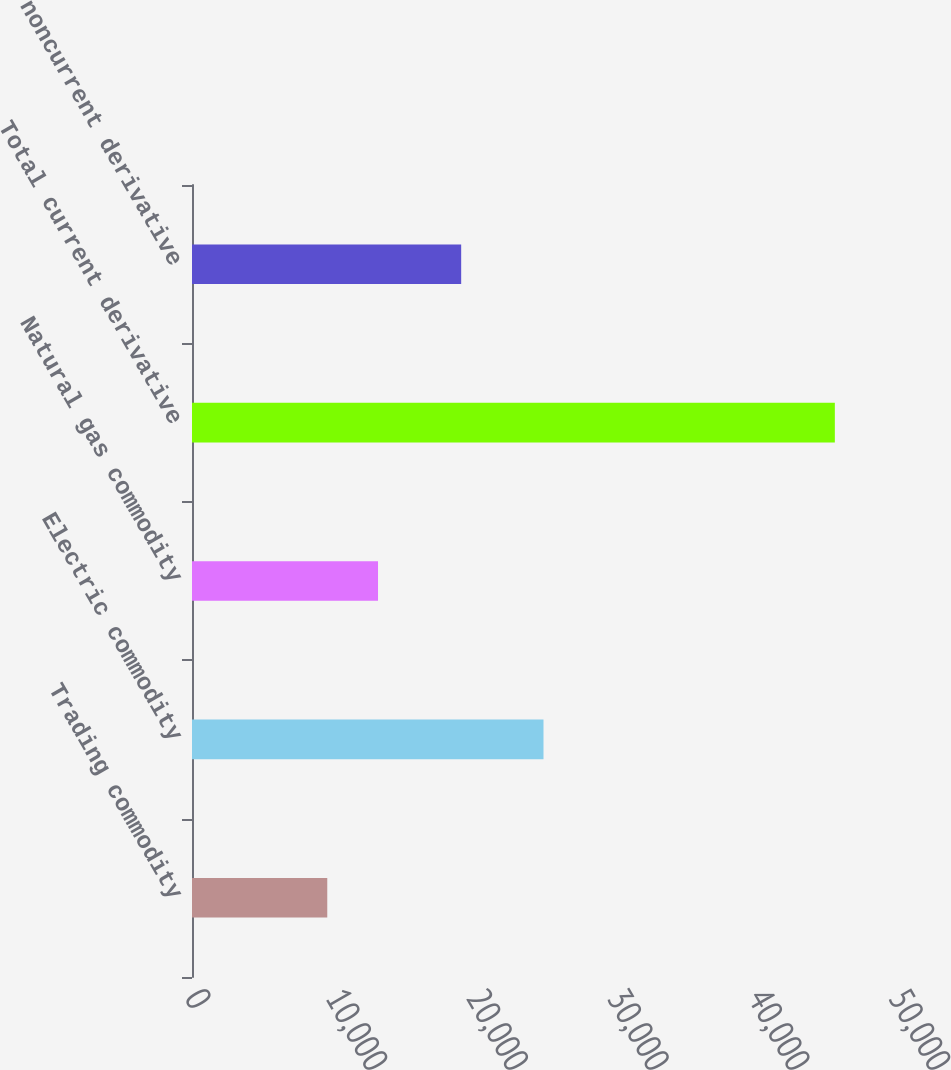<chart> <loc_0><loc_0><loc_500><loc_500><bar_chart><fcel>Trading commodity<fcel>Electric commodity<fcel>Natural gas commodity<fcel>Total current derivative<fcel>Total noncurrent derivative<nl><fcel>9607<fcel>24965<fcel>13212<fcel>45657<fcel>19118<nl></chart> 